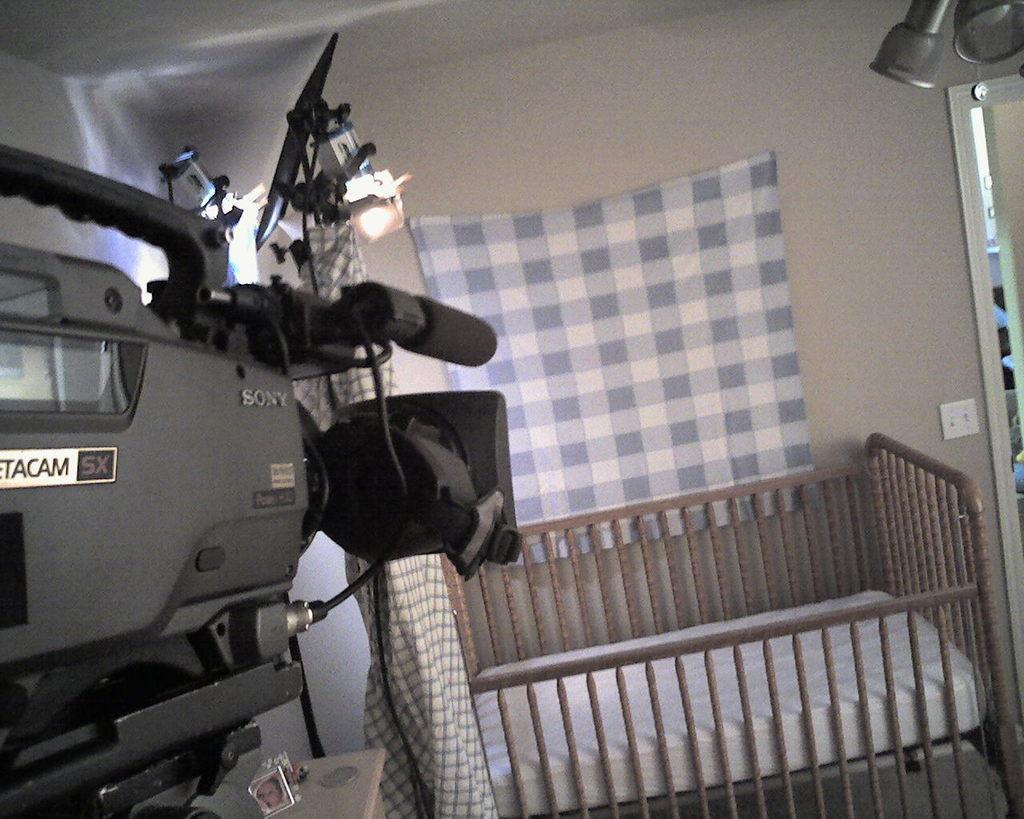What is hanging on the wall in the image? There is a cloth on the wall in the image. What type of furniture is present in the image? There is a baby bed frame and a bed in the image. What device is located on the left side of the image? There is a cam recorder on the left side of the image. Can you describe any other objects visible in the image? There are additional objects visible in the image, but their specific details are not mentioned in the provided facts. How is the iron being distributed in the image? There is no iron present in the image, so it cannot be distributed. 